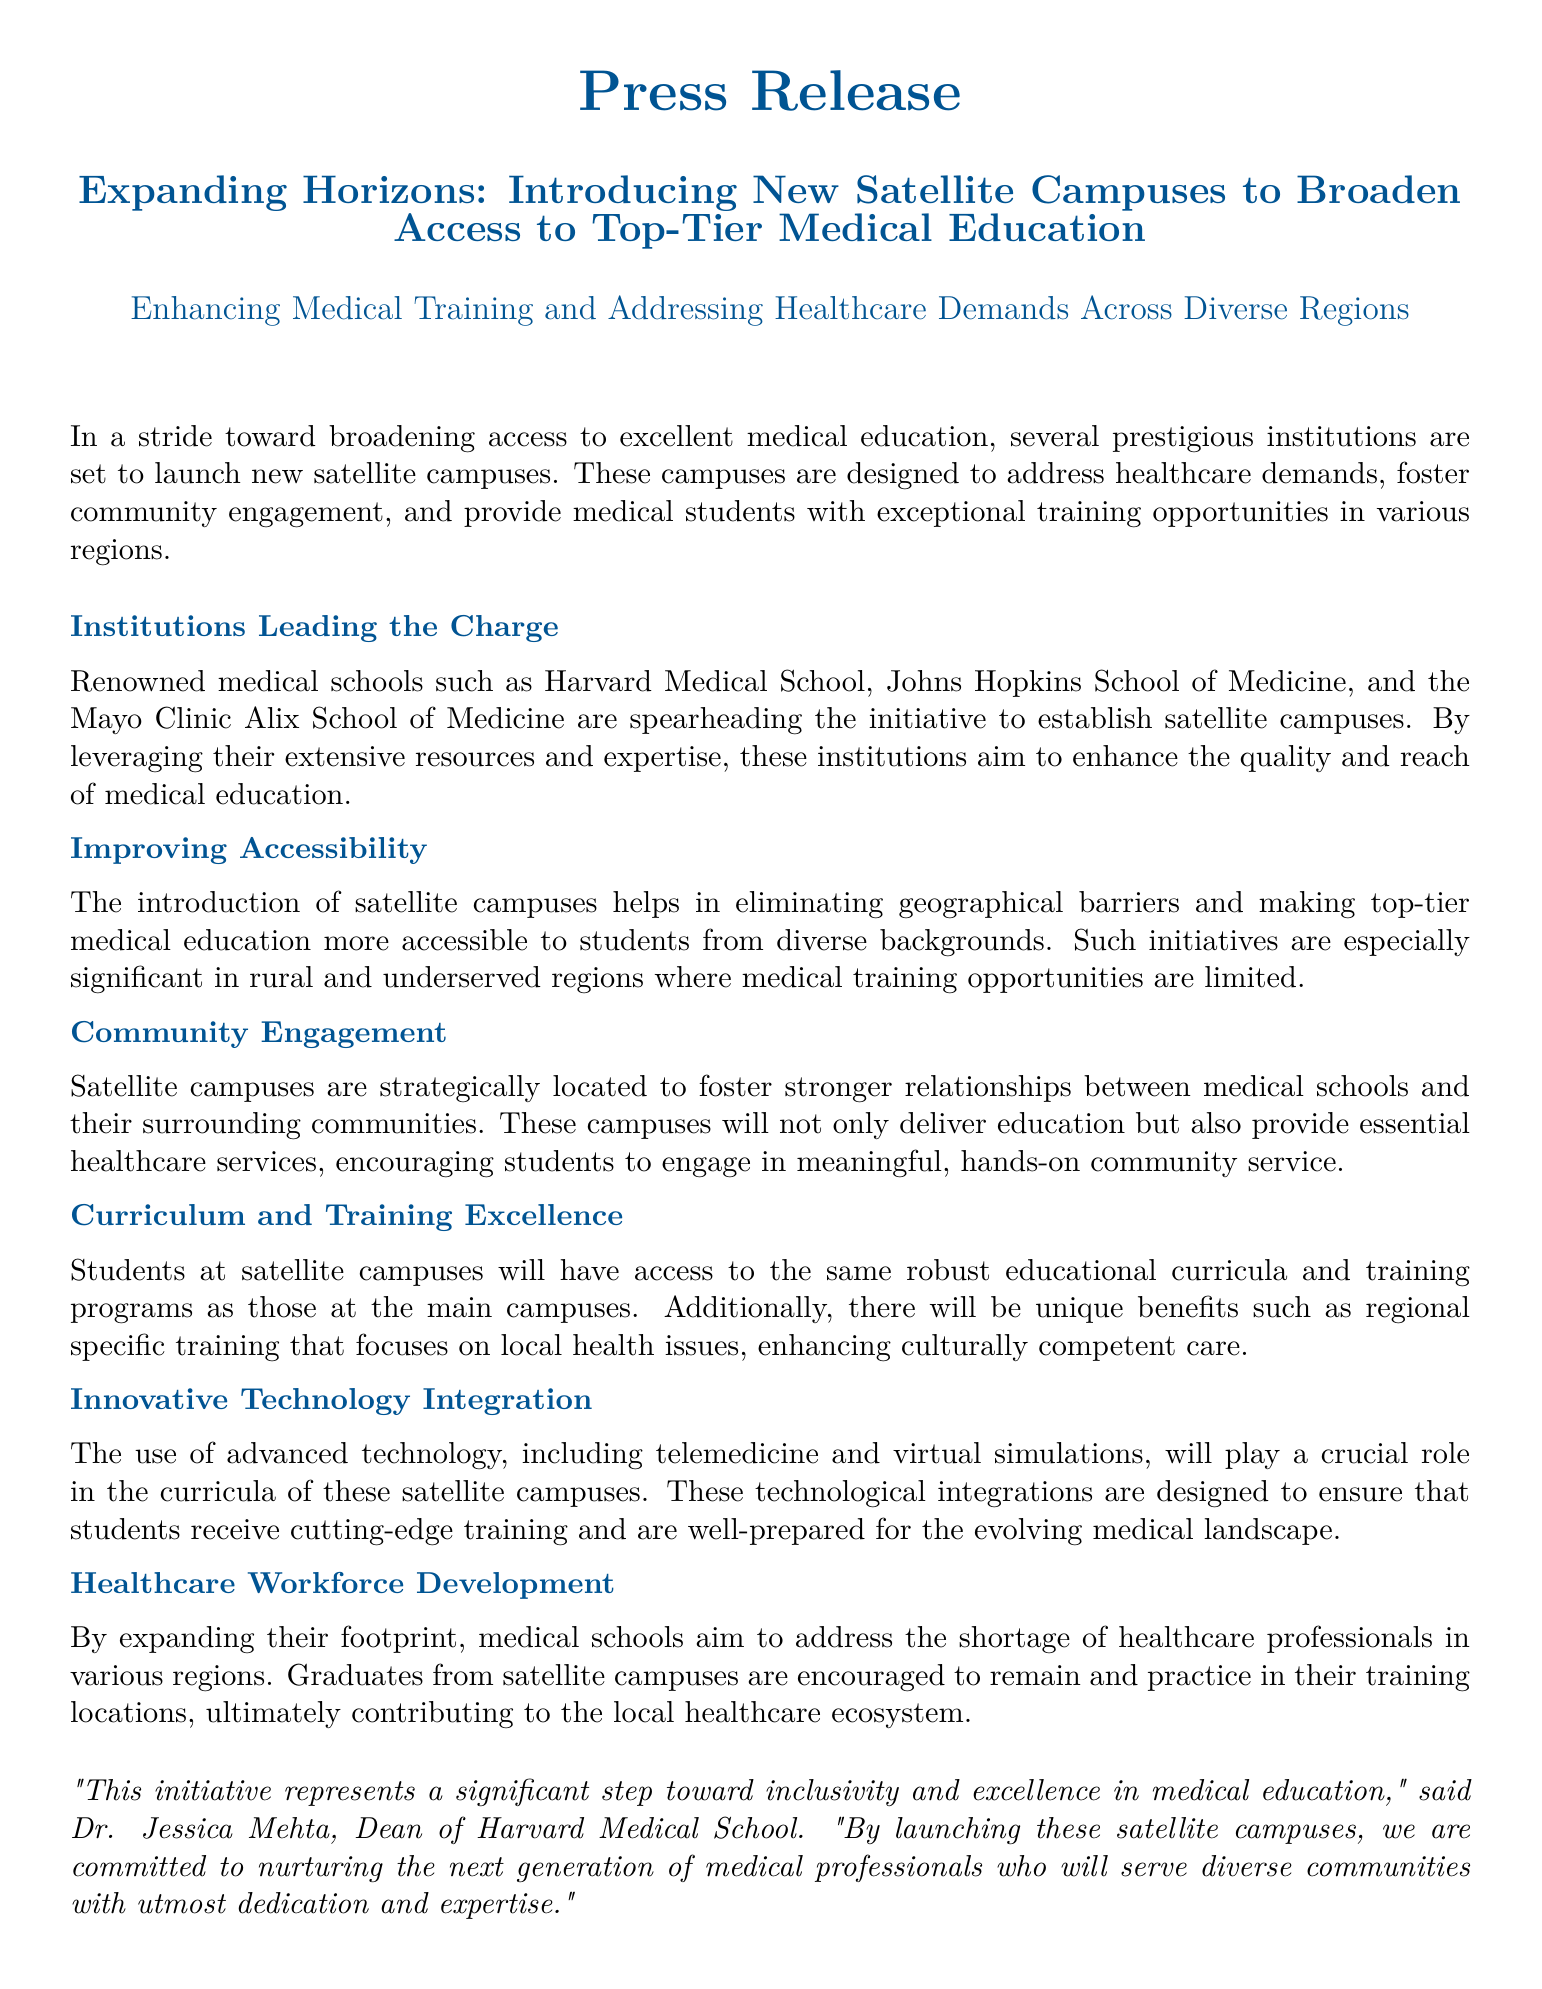What is the title of the press release? The title provides a summary of the main topic discussed in the document, which is "Expanding Horizons: Introducing New Satellite Campuses to Broaden Access to Top-Tier Medical Education".
Answer: Expanding Horizons: Introducing New Satellite Campuses to Broaden Access to Top-Tier Medical Education Which institutions are leading the initiative? The document lists the prominent institutions involved in launching satellite campuses, which include Harvard Medical School, Johns Hopkins School of Medicine, and the Mayo Clinic Alix School of Medicine.
Answer: Harvard Medical School, Johns Hopkins School of Medicine, and the Mayo Clinic Alix School of Medicine What is the purpose of the new satellite campuses? The satellite campuses aim to address healthcare demands, foster community engagement, and provide exceptional training opportunities in various regions.
Answer: To address healthcare demands, foster community engagement, and provide exceptional training opportunities Who is the Dean of Harvard Medical School mentioned in the document? The document cites a quote from Dr. Jessica Mehta, who serves as the Dean of Harvard Medical School and speaks about the initiative.
Answer: Dr. Jessica Mehta What are students at satellite campuses encouraged to do after graduation? The document states that graduates from satellite campuses are encouraged to stay and practice in their training locations, contributing to the local healthcare ecosystem.
Answer: Stay and practice in their training locations What major technology will influence the curricula at satellite campuses? The press release mentions the integration of advanced technology, specifically telemedicine and virtual simulations, as significant in the training provided at satellite campuses.
Answer: Telemedicine and virtual simulations 